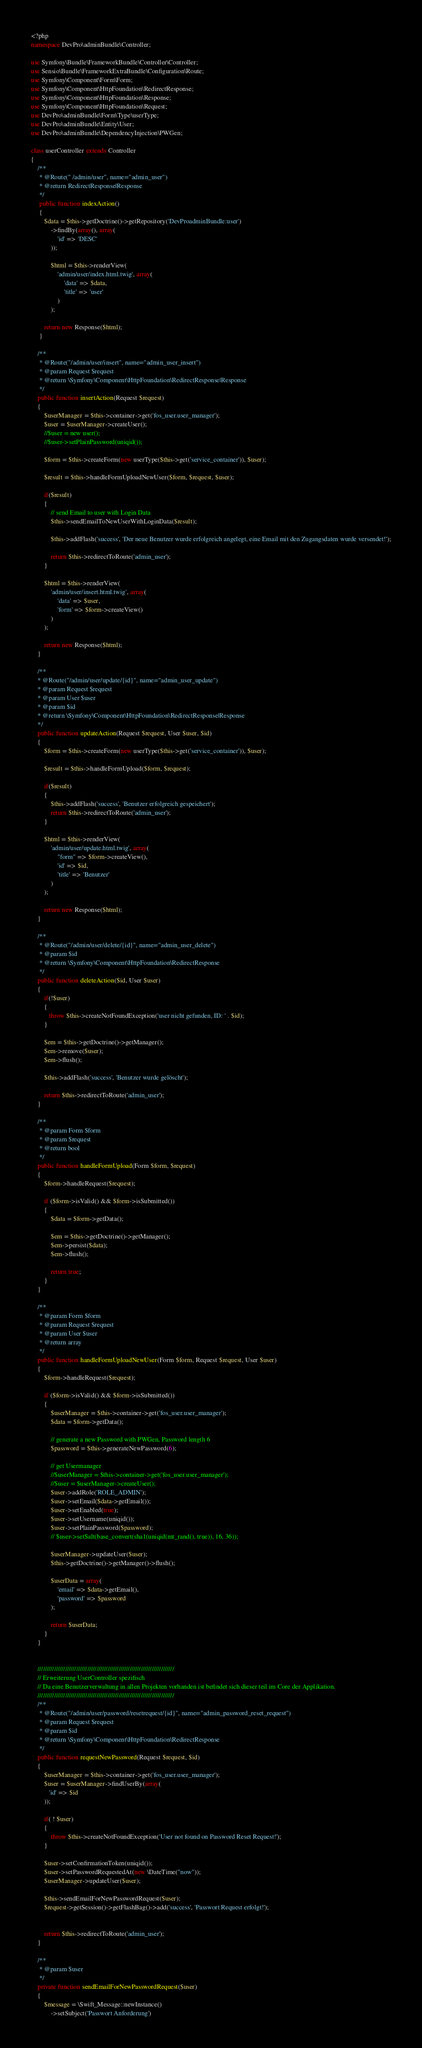<code> <loc_0><loc_0><loc_500><loc_500><_PHP_><?php
namespace DevPro\adminBundle\Controller;

use Symfony\Bundle\FrameworkBundle\Controller\Controller;
use Sensio\Bundle\FrameworkExtraBundle\Configuration\Route;
use Symfony\Component\Form\Form;
use Symfony\Component\HttpFoundation\RedirectResponse;
use Symfony\Component\HttpFoundation\Response;
use Symfony\Component\HttpFoundation\Request;
use DevPro\adminBundle\Form\Type\userType;
use DevPro\adminBundle\Entity\User;
use DevPro\adminBundle\DependencyInjection\PWGen;

class userController extends Controller
{
    /**
     * @Route(" /admin/user", name="admin_user")
     * @return RedirectResponse|Response
     */
     public function indexAction()
     {
        $data = $this->getDoctrine()->getRepository('DevProadminBundle:user')
            ->findBy(array(), array(
                'id' => 'DESC'
            ));

            $html = $this->renderView(
                'admin/user/index.html.twig', array(
                    'data' => $data,
                    'title' => 'user'
                )
            );

        return new Response($html);
     }

    /**
     * @Route("/admin/user/insert", name="admin_user_insert")
     * @param Request $request
     * @return \Symfony\Component\HttpFoundation\RedirectResponse|Response
     */
    public function insertAction(Request $request)
    {
        $userManager = $this->container->get('fos_user.user_manager');
        $user = $userManager->createUser();
        //$user = new user();
        //$user->setPlainPassword(uniqid());

        $form = $this->createForm(new userType($this->get('service_container')), $user);

        $result = $this->handleFormUploadNewUser($form, $request, $user);

        if($result)
        {
            // send Email to user with Login Data
            $this->sendEmailToNewUserWithLoginData($result);

            $this->addFlash('success', 'Der neue Benutzer wurde erfolgreich angelegt, eine Email mit den Zugangsdaten wurde versendet!');

            return $this->redirectToRoute('admin_user');
        }

        $html = $this->renderView(
            'admin/user/insert.html.twig', array(
                'data' => $user,
                'form' => $form->createView()
            )
        );

        return new Response($html);
    }

    /**
    * @Route("/admin/user/update/{id}", name="admin_user_update")
    * @param Request $request
    * @param User $user
    * @param $id
    * @return \Symfony\Component\HttpFoundation\RedirectResponse|Response
    */
    public function updateAction(Request $request, User $user, $id)
    {
        $form = $this->createForm(new userType($this->get('service_container')), $user);

        $result = $this->handleFormUpload($form, $request);

        if($result)
        {
            $this->addFlash('success', 'Benutzer erfolgreich gespeichert');
            return $this->redirectToRoute('admin_user');
        }

        $html = $this->renderView(
            'admin/user/update.html.twig', array(
                "form" => $form->createView(),
                'id' => $id,
                'title' => 'Benutzer'
            )
        );

        return new Response($html);
    }

    /**
     * @Route("/admin/user/delete/{id}", name="admin_user_delete")
     * @param $id
     * @return \Symfony\Component\HttpFoundation\RedirectResponse
     */
    public function deleteAction($id, User $user)
    {
        if(!$user)
        {
           throw $this->createNotFoundException('user nicht gefunden, ID: ' . $id);
        }

        $em = $this->getDoctrine()->getManager();
        $em->remove($user);
        $em->flush();

        $this->addFlash('success', 'Benutzer wurde gelöscht');

        return $this->redirectToRoute('admin_user');
    }

    /**
     * @param Form $form
     * @param $request
     * @return bool
     */
    public function handleFormUpload(Form $form, $request)
    {
        $form->handleRequest($request);

        if ($form->isValid() && $form->isSubmitted())
        {
            $data = $form->getData();

            $em = $this->getDoctrine()->getManager();
            $em->persist($data);
            $em->flush();

            return true;
        }
    }

    /**
     * @param Form $form
     * @param Request $request
     * @param User $user
     * @return array
     */
    public function handleFormUploadNewUser(Form $form, Request $request, User $user)
    {
        $form->handleRequest($request);

        if ($form->isValid() && $form->isSubmitted())
        {
            $userManager = $this->container->get('fos_user.user_manager');
            $data = $form->getData();

            // generate a new Password with PWGen, Password length 6
            $password = $this->generateNewPassword(6);

            // get Usermanager
            //$userManager = $this->container->get('fos_user.user_manager');
            //$user = $userManager->createUser();
            $user->addRole('ROLE_ADMIN');
            $user->setEmail($data->getEmail());
            $user->setEnabled(true);
            $user->setUsername(uniqid());
            $user->setPlainPassword($password);
            // $user->setSalt(base_convert(sha1(uniqid(mt_rand(), true)), 16, 36));

            $userManager->updateUser($user);
            $this->getDoctrine()->getManager()->flush();

            $userData = array(
                'email' => $data->getEmail(),
                'password' => $password
            );

            return $userData;
        }
    }


    //////////////////////////////////////////////////////////////////////////
    // Erweiterung UserController spezifisch
    // Da eine Benutzerverwaltung in allen Projekten vorhanden ist befindet sich dieser teil im Core der Applikation.
    //////////////////////////////////////////////////////////////////////////
    /**
     * @Route("/admin/user/password/resetrequest/{id}", name="admin_password_reset_request")
     * @param Request $request
     * @param $id
     * @return \Symfony\Component\HttpFoundation\RedirectResponse
     */
    public function requestNewPassword(Request $request, $id)
    {
        $userManager = $this->container->get('fos_user.user_manager');
        $user = $userManager->findUserBy(array(
           'id' => $id
        ));

        if( ! $user)
        {
            throw $this->createNotFoundException('User not found on Password Reset Request!');
        }

        $user->setConfirmationToken(uniqid());
        $user->setPasswordRequestedAt(new \DateTime("now"));
        $userManager->updateUser($user);

        $this->sendEmailForNewPasswordRequest($user);
        $request->getSession()->getFlashBag()->add('success', 'Passwort Request erfolgt!');


        return $this->redirectToRoute('admin_user');
    }

    /**
     * @param $user
     */
    private function sendEmailForNewPasswordRequest($user)
    {
        $message = \Swift_Message::newInstance()
            ->setSubject('Passwort Anforderung')</code> 